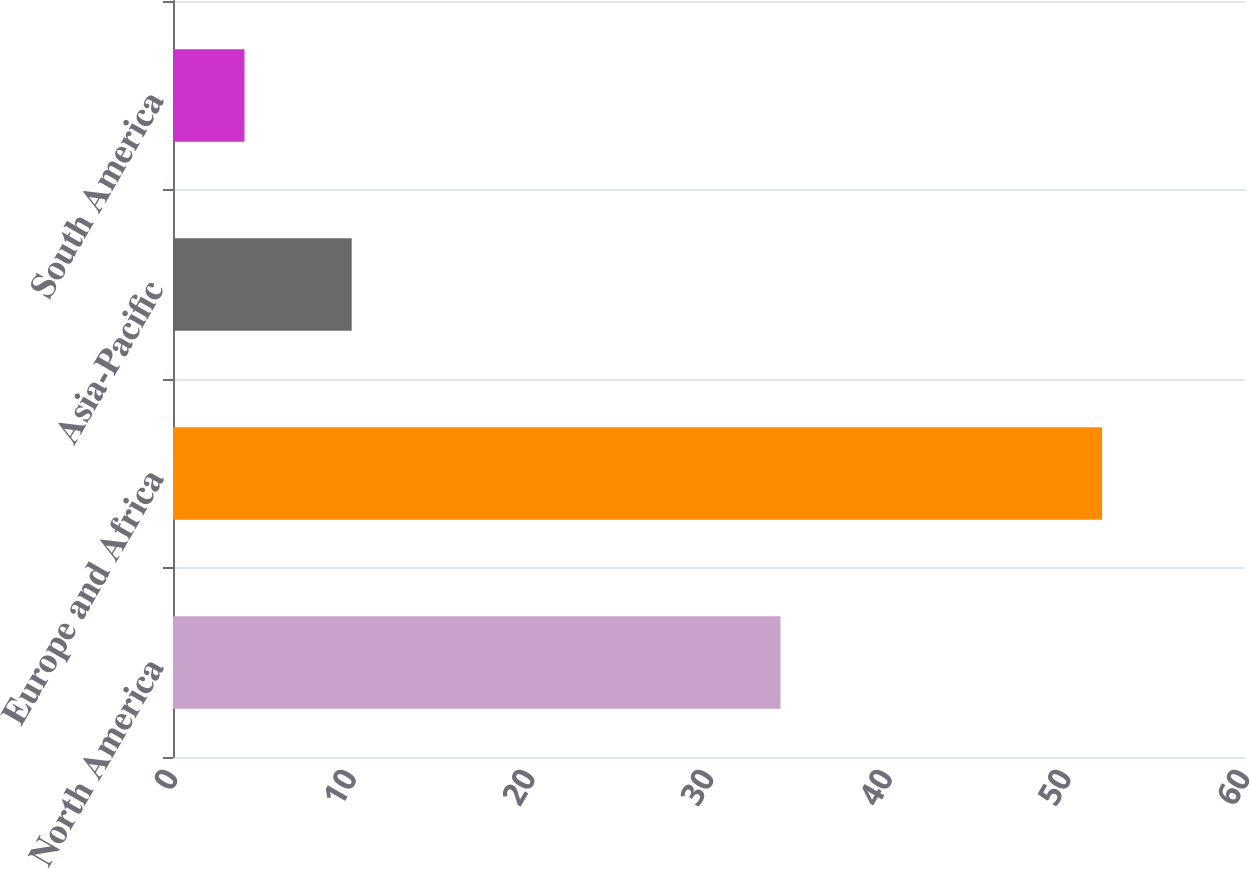<chart> <loc_0><loc_0><loc_500><loc_500><bar_chart><fcel>North America<fcel>Europe and Africa<fcel>Asia-Pacific<fcel>South America<nl><fcel>34<fcel>52<fcel>10<fcel>4<nl></chart> 